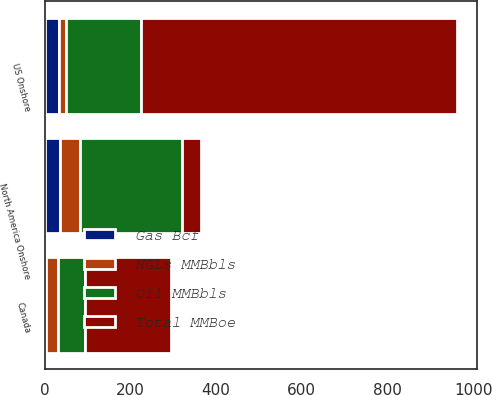Convert chart. <chart><loc_0><loc_0><loc_500><loc_500><stacked_bar_chart><ecel><fcel>US Onshore<fcel>Canada<fcel>North America Onshore<nl><fcel>NGLs MMBbls<fcel>17<fcel>28<fcel>45<nl><fcel>Total MMBoe<fcel>736<fcel>199<fcel>45<nl><fcel>Gas Bcf<fcel>34<fcel>3<fcel>37<nl><fcel>Oil MMBbls<fcel>174<fcel>64<fcel>238<nl></chart> 